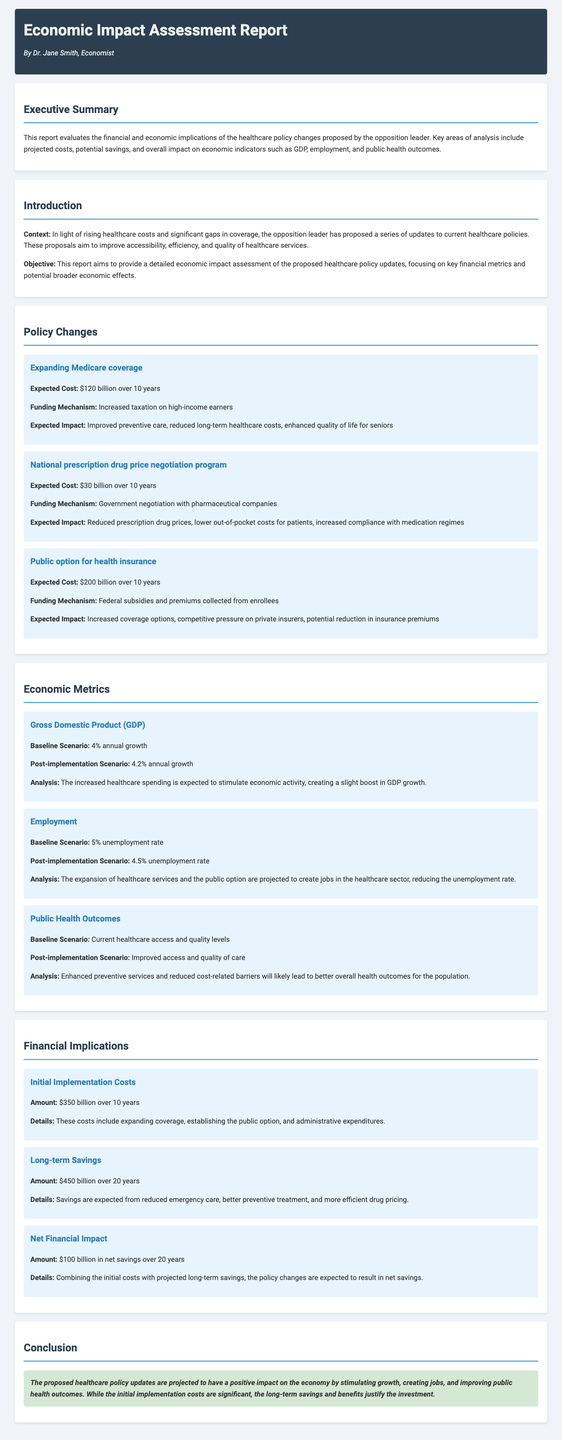What is the expected cost of expanding Medicare coverage? The expected cost is stated in the document under the policy change section for Medicare coverage, which is $120 billion over 10 years.
Answer: $120 billion over 10 years What are the projected long-term savings from the healthcare policy changes? The long-term savings are mentioned in the financial implications section, amounting to $450 billion over 20 years.
Answer: $450 billion over 20 years What is the baseline unemployment rate mentioned? The baseline unemployment rate is provided in the economic metrics section, which is 5%.
Answer: 5% What is the expected impact of the public option for health insurance? The expected impact is detailed in the policy changes section, indicating increased coverage options and potential reduction in insurance premiums.
Answer: Increased coverage options, competitive pressure on private insurers, potential reduction in insurance premiums What is the initial implementation cost of the proposed changes? The initial implementation costs can be found in the financial implications section and are noted as $350 billion over 10 years.
Answer: $350 billion over 10 years What is the post-implementation scenario for GDP growth? The post-implementation scenario for GDP growth is described in the economic metrics section as an increase to 4.2% annual growth.
Answer: 4.2% annual growth What is the net financial impact expected over 20 years? The document specifies the net financial impact in the financial implications section, indicating $100 billion in net savings.
Answer: $100 billion in net savings What are the expected improvements in public health outcomes? The desired health outcomes are outlined in the economic metrics section, emphasizing improved access and quality of care.
Answer: Improved access and quality of care 